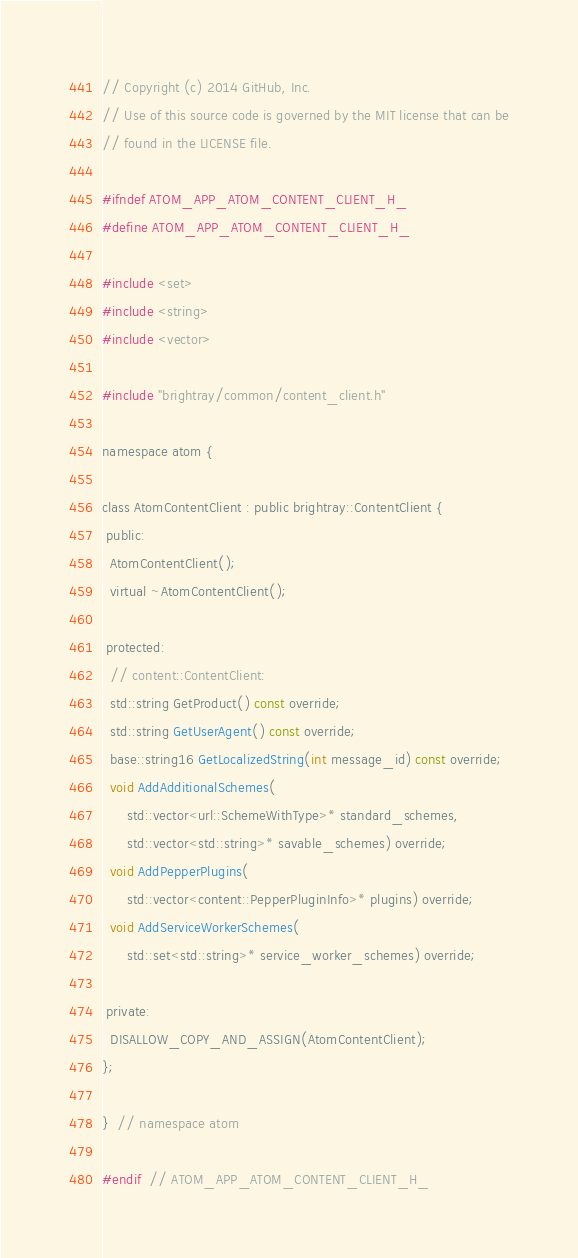Convert code to text. <code><loc_0><loc_0><loc_500><loc_500><_C_>// Copyright (c) 2014 GitHub, Inc.
// Use of this source code is governed by the MIT license that can be
// found in the LICENSE file.

#ifndef ATOM_APP_ATOM_CONTENT_CLIENT_H_
#define ATOM_APP_ATOM_CONTENT_CLIENT_H_

#include <set>
#include <string>
#include <vector>

#include "brightray/common/content_client.h"

namespace atom {

class AtomContentClient : public brightray::ContentClient {
 public:
  AtomContentClient();
  virtual ~AtomContentClient();

 protected:
  // content::ContentClient:
  std::string GetProduct() const override;
  std::string GetUserAgent() const override;
  base::string16 GetLocalizedString(int message_id) const override;
  void AddAdditionalSchemes(
      std::vector<url::SchemeWithType>* standard_schemes,
      std::vector<std::string>* savable_schemes) override;
  void AddPepperPlugins(
      std::vector<content::PepperPluginInfo>* plugins) override;
  void AddServiceWorkerSchemes(
      std::set<std::string>* service_worker_schemes) override;

 private:
  DISALLOW_COPY_AND_ASSIGN(AtomContentClient);
};

}  // namespace atom

#endif  // ATOM_APP_ATOM_CONTENT_CLIENT_H_
</code> 